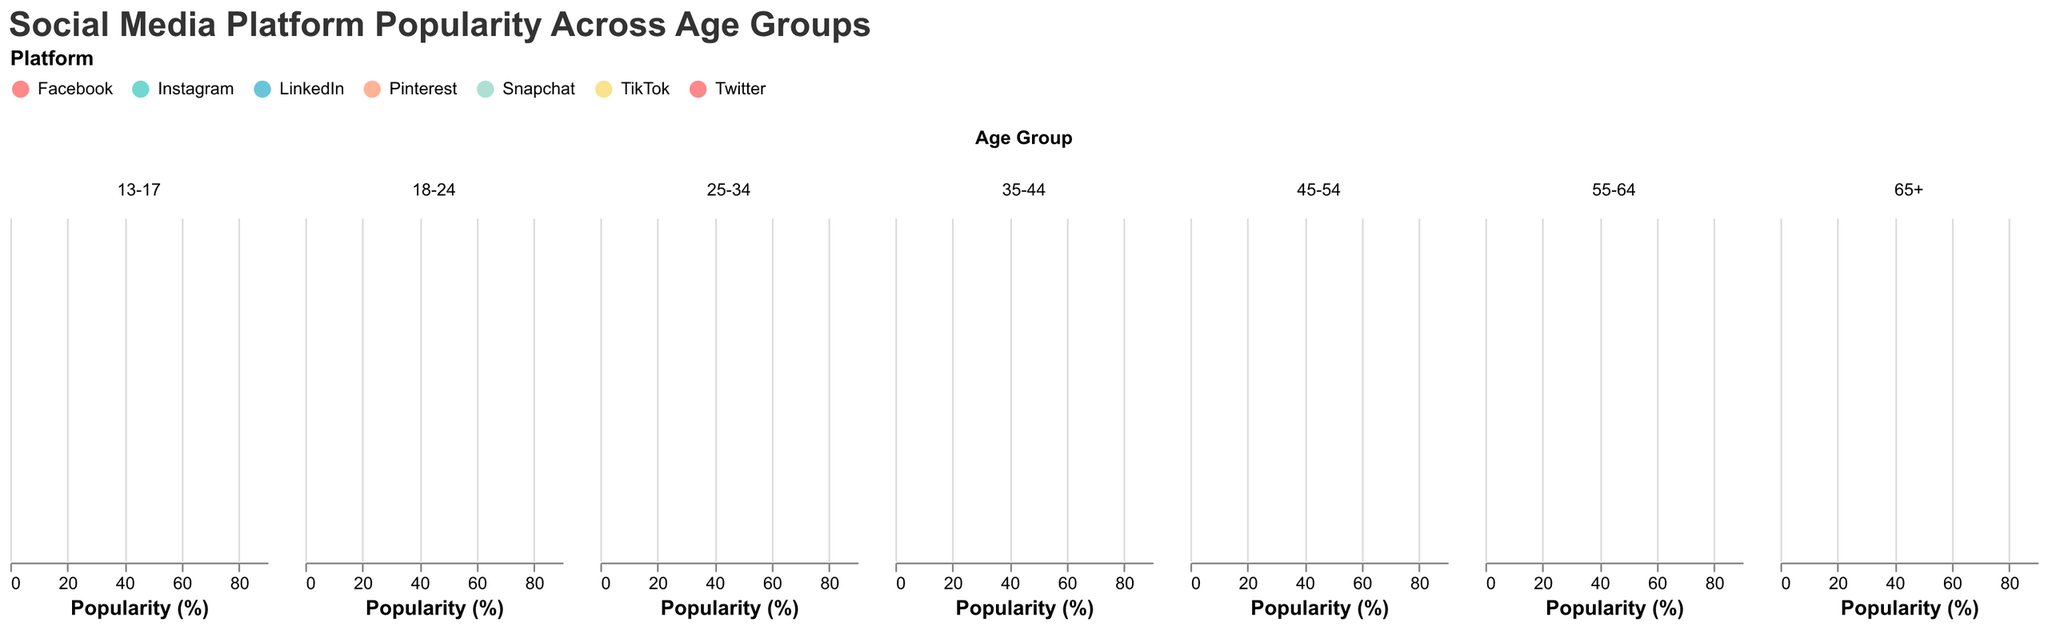How popular is Instagram among 13-17-year-olds? The density plot for 13-17-year-olds shows that Instagram has a popularity of 75%.
Answer: 75 Which social media platform is the least popular among 18-24-year-olds? The density plot for 18-24-year-olds indicates that Snapchat is the least popular, with a popularity of 55%.
Answer: Snapchat What is the difference in popularity of Facebook between the 25-34 and 55-64 age groups? Facebook's popularity in the 25-34 age group is 45%, while in the 55-64 age group, it is 70%. The difference is 70% - 45% = 25%.
Answer: 25 Which age group shows the highest popularity for TikTok? By comparing the density plots for each age group, the 13-17 age group has the highest popularity for TikTok, at 85%.
Answer: 13-17 What is the average popularity of LinkedIn across all age groups? Sum the popularity values for LinkedIn across all age groups (25 + 30 + 40 + 50 + 45 = 190) and divide by the number of age groups (5). The average is 190 / 5 = 38.
Answer: 38 How does the popularity of Pinterest compare to LinkedIn in the 45-54 age group? In the 45-54 age group, Pinterest has a popularity of 35%, while LinkedIn has a popularity of 40%. Pinterest’s popularity is 5% less than LinkedIn’s.
Answer: 5% less Which platform is more popular among the 35-44 age group, Instagram or Twitter? The density plot for the 35-44 age group shows Instagram with a popularity of 50% and Twitter with a popularity of 35%. Thus, Instagram is more popular.
Answer: Instagram Is Facebook more popular with the 65+ age group compared to the 25-34 age group? Facebook’s popularity in the 65+ age group is 65%, while it is 45% in the 25-34 age group. Thus, it is more popular among the 65+ age group.
Answer: Yes 